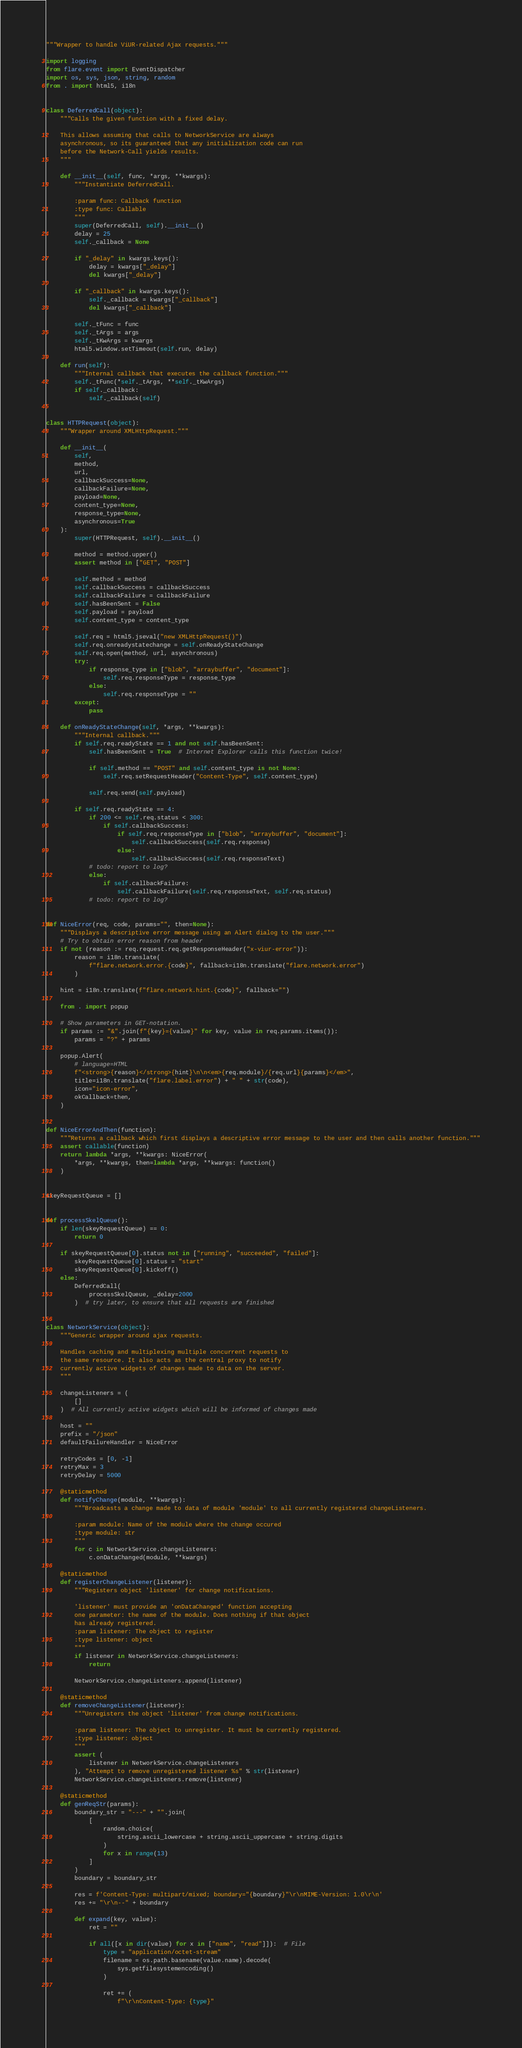<code> <loc_0><loc_0><loc_500><loc_500><_Python_>"""Wrapper to handle ViUR-related Ajax requests."""

import logging
from flare.event import EventDispatcher
import os, sys, json, string, random
from . import html5, i18n


class DeferredCall(object):
    """Calls the given function with a fixed delay.

    This allows assuming that calls to NetworkService are always
    asynchronous, so its guaranteed that any initialization code can run
    before the Network-Call yields results.
    """

    def __init__(self, func, *args, **kwargs):
        """Instantiate DeferredCall.

        :param func: Callback function
        :type func: Callable
        """
        super(DeferredCall, self).__init__()
        delay = 25
        self._callback = None

        if "_delay" in kwargs.keys():
            delay = kwargs["_delay"]
            del kwargs["_delay"]

        if "_callback" in kwargs.keys():
            self._callback = kwargs["_callback"]
            del kwargs["_callback"]

        self._tFunc = func
        self._tArgs = args
        self._tKwArgs = kwargs
        html5.window.setTimeout(self.run, delay)

    def run(self):
        """Internal callback that executes the callback function."""
        self._tFunc(*self._tArgs, **self._tKwArgs)
        if self._callback:
            self._callback(self)


class HTTPRequest(object):
    """Wrapper around XMLHttpRequest."""

    def __init__(
        self,
        method,
        url,
        callbackSuccess=None,
        callbackFailure=None,
        payload=None,
        content_type=None,
        response_type=None,
        asynchronous=True
    ):
        super(HTTPRequest, self).__init__()

        method = method.upper()
        assert method in ["GET", "POST"]

        self.method = method
        self.callbackSuccess = callbackSuccess
        self.callbackFailure = callbackFailure
        self.hasBeenSent = False
        self.payload = payload
        self.content_type = content_type

        self.req = html5.jseval("new XMLHttpRequest()")
        self.req.onreadystatechange = self.onReadyStateChange
        self.req.open(method, url, asynchronous)
        try:
            if response_type in ["blob", "arraybuffer", "document"]:
                self.req.responseType = response_type
            else:
                self.req.responseType = ""
        except:
            pass

    def onReadyStateChange(self, *args, **kwargs):
        """Internal callback."""
        if self.req.readyState == 1 and not self.hasBeenSent:
            self.hasBeenSent = True  # Internet Explorer calls this function twice!

            if self.method == "POST" and self.content_type is not None:
                self.req.setRequestHeader("Content-Type", self.content_type)

            self.req.send(self.payload)

        if self.req.readyState == 4:
            if 200 <= self.req.status < 300:
                if self.callbackSuccess:
                    if self.req.responseType in ["blob", "arraybuffer", "document"]:
                        self.callbackSuccess(self.req.response)
                    else:
                        self.callbackSuccess(self.req.responseText)
            # todo: report to log?
            else:
                if self.callbackFailure:
                    self.callbackFailure(self.req.responseText, self.req.status)
            # todo: report to log?


def NiceError(req, code, params="", then=None):
    """Displays a descriptive error message using an Alert dialog to the user."""
    # Try to obtain error reason from header
    if not (reason := req.request.req.getResponseHeader("x-viur-error")):
        reason = i18n.translate(
            f"flare.network.error.{code}", fallback=i18n.translate("flare.network.error")
        )

    hint = i18n.translate(f"flare.network.hint.{code}", fallback="")

    from . import popup

    # Show parameters in GET-notation.
    if params := "&".join(f"{key}={value}" for key, value in req.params.items()):
        params = "?" + params

    popup.Alert(
        # language=HTML
        f"<strong>{reason}</strong>{hint}\n\n<em>{req.module}/{req.url}{params}</em>",
        title=i18n.translate("flare.label.error") + " " + str(code),
        icon="icon-error",
        okCallback=then,
    )


def NiceErrorAndThen(function):
    """Returns a callback which first displays a descriptive error message to the user and then calls another function."""
    assert callable(function)
    return lambda *args, **kwargs: NiceError(
        *args, **kwargs, then=lambda *args, **kwargs: function()
    )


skeyRequestQueue = []


def processSkelQueue():
    if len(skeyRequestQueue) == 0:
        return 0

    if skeyRequestQueue[0].status not in ["running", "succeeded", "failed"]:
        skeyRequestQueue[0].status = "start"
        skeyRequestQueue[0].kickoff()
    else:
        DeferredCall(
            processSkelQueue, _delay=2000
        )  # try later, to ensure that all requests are finished


class NetworkService(object):
    """Generic wrapper around ajax requests.

    Handles caching and multiplexing multiple concurrent requests to
    the same resource. It also acts as the central proxy to notify
    currently active widgets of changes made to data on the server.
    """

    changeListeners = (
        []
    )  # All currently active widgets which will be informed of changes made

    host = ""
    prefix = "/json"
    defaultFailureHandler = NiceError

    retryCodes = [0, -1]
    retryMax = 3
    retryDelay = 5000

    @staticmethod
    def notifyChange(module, **kwargs):
        """Broadcasts a change made to data of module 'module' to all currently registered changeListeners.

        :param module: Name of the module where the change occured
        :type module: str
        """
        for c in NetworkService.changeListeners:
            c.onDataChanged(module, **kwargs)

    @staticmethod
    def registerChangeListener(listener):
        """Registers object 'listener' for change notifications.

        'listener' must provide an 'onDataChanged' function accepting
        one parameter: the name of the module. Does nothing if that object
        has already registered.
        :param listener: The object to register
        :type listener: object
        """
        if listener in NetworkService.changeListeners:
            return

        NetworkService.changeListeners.append(listener)

    @staticmethod
    def removeChangeListener(listener):
        """Unregisters the object 'listener' from change notifications.

        :param listener: The object to unregister. It must be currently registered.
        :type listener: object
        """
        assert (
            listener in NetworkService.changeListeners
        ), "Attempt to remove unregistered listener %s" % str(listener)
        NetworkService.changeListeners.remove(listener)

    @staticmethod
    def genReqStr(params):
        boundary_str = "---" + "".join(
            [
                random.choice(
                    string.ascii_lowercase + string.ascii_uppercase + string.digits
                )
                for x in range(13)
            ]
        )
        boundary = boundary_str

        res = f'Content-Type: multipart/mixed; boundary="{boundary}"\r\nMIME-Version: 1.0\r\n'
        res += "\r\n--" + boundary

        def expand(key, value):
            ret = ""

            if all([x in dir(value) for x in ["name", "read"]]):  # File
                type = "application/octet-stream"
                filename = os.path.basename(value.name).decode(
                    sys.getfilesystemencoding()
                )

                ret += (
                    f"\r\nContent-Type: {type}"</code> 